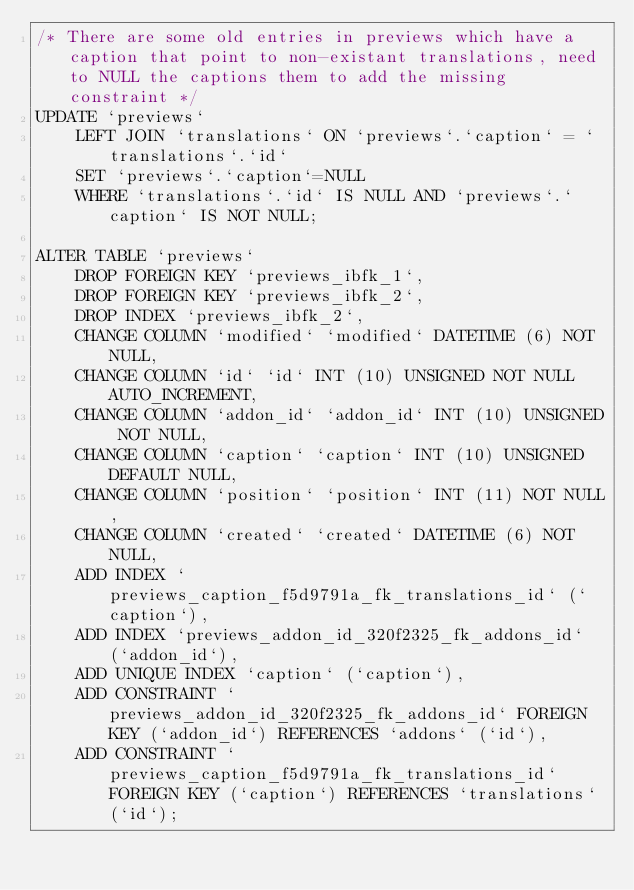Convert code to text. <code><loc_0><loc_0><loc_500><loc_500><_SQL_>/* There are some old entries in previews which have a caption that point to non-existant translations, need to NULL the captions them to add the missing constraint */
UPDATE `previews`
    LEFT JOIN `translations` ON `previews`.`caption` = `translations`.`id`
    SET `previews`.`caption`=NULL
    WHERE `translations`.`id` IS NULL AND `previews`.`caption` IS NOT NULL;

ALTER TABLE `previews`
    DROP FOREIGN KEY `previews_ibfk_1`,
    DROP FOREIGN KEY `previews_ibfk_2`,
    DROP INDEX `previews_ibfk_2`,
    CHANGE COLUMN `modified` `modified` DATETIME (6) NOT NULL,
    CHANGE COLUMN `id` `id` INT (10) UNSIGNED NOT NULL AUTO_INCREMENT,
    CHANGE COLUMN `addon_id` `addon_id` INT (10) UNSIGNED NOT NULL,
    CHANGE COLUMN `caption` `caption` INT (10) UNSIGNED DEFAULT NULL,
    CHANGE COLUMN `position` `position` INT (11) NOT NULL,
    CHANGE COLUMN `created` `created` DATETIME (6) NOT NULL,
    ADD INDEX `previews_caption_f5d9791a_fk_translations_id` (`caption`),
    ADD INDEX `previews_addon_id_320f2325_fk_addons_id` (`addon_id`),
    ADD UNIQUE INDEX `caption` (`caption`),
    ADD CONSTRAINT `previews_addon_id_320f2325_fk_addons_id` FOREIGN KEY (`addon_id`) REFERENCES `addons` (`id`),
    ADD CONSTRAINT `previews_caption_f5d9791a_fk_translations_id` FOREIGN KEY (`caption`) REFERENCES `translations` (`id`);
</code> 